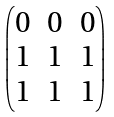Convert formula to latex. <formula><loc_0><loc_0><loc_500><loc_500>\begin{pmatrix} 0 & 0 & 0 \\ 1 & 1 & 1 \\ 1 & 1 & 1 \end{pmatrix}</formula> 